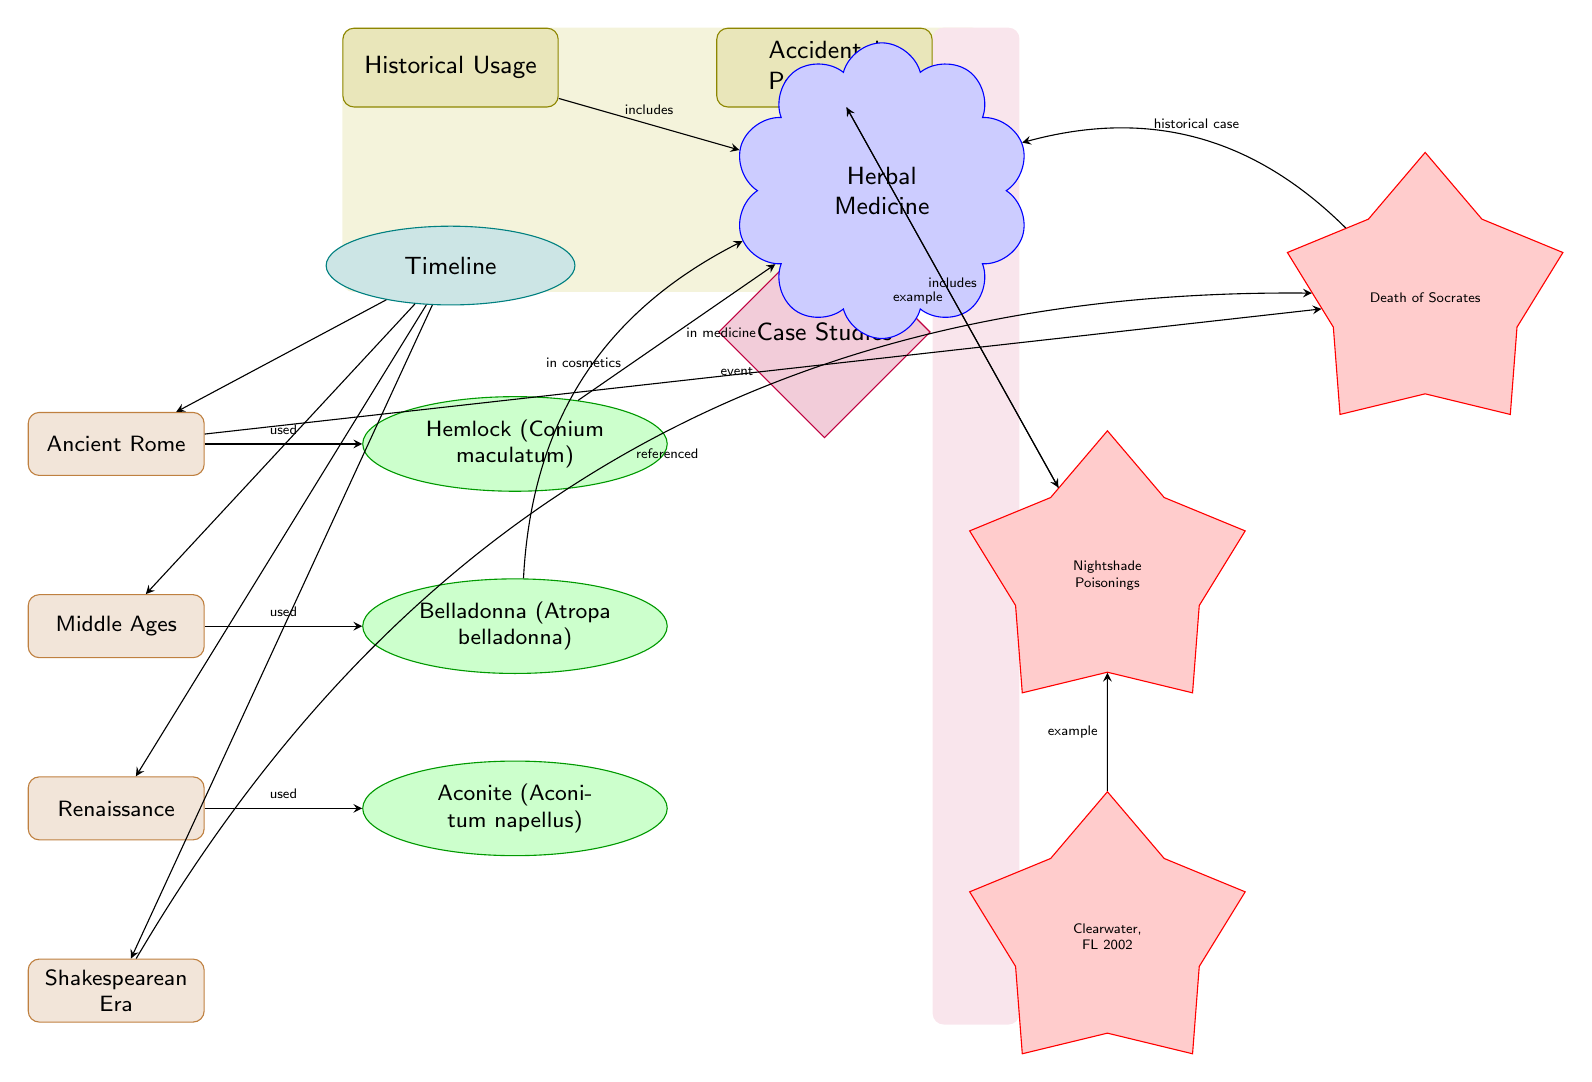What historical figure is associated with Hemlock? The diagram indicates that Socrates is linked to Hemlock as a historical figure through the label "Death of Socrates" directly connected to the Hemlock node. This implies that Socrates was known to have died from Hemlock poisoning.
Answer: Socrates How many historical periods are represented in the diagram? By examining the timeline section of the diagram, we can identify four distinct historical periods: Ancient Rome, Middle Ages, Renaissance, and Shakespearean Era. Therefore, the total count of historical periods is four.
Answer: 4 What plant is noted for its use in cosmetics? The diagram shows that Belladonna is linked specifically to the "in cosmetics" label, which signifies that this plant has historical usage in cosmetic applications.
Answer: Belladonna Which historical period is related to the usage of Aconite? Aconite is shown in the diagram under the Renaissance period, connected directly through the label "used," indicating that Aconite was utilized during that time.
Answer: Renaissance What is the example case of accidental poisoning listed for 2002? The diagram mentions "Clearwater, FL 2002" as an example of an accidental poisoning case associated with Nightshade, indicating that this specific incident occurred in Clearwater, Florida, in the year 2002.
Answer: Clearwater, FL 2002 Which plant is connected to herbal medicine? The diagram connects Hemlock to the herbal medicine category, indicating that Hemlock has been used historically in herbal medicinal practices.
Answer: Hemlock What notable historical case is associated with the love of Socrates? The diagram connects Socrates to the "historical case" label, further specifying that his death from Hemlock poisoning is a significant historical case related to the use of this poisonous plant.
Answer: Death of Socrates Name the category of the node that includes "Nightshade Poisonings." The node for "Nightshade Poisonings" is included within the "Accidental Poisonings" category, indicating that it falls under this classification of poisonings in the diagram.
Answer: Accidental Poisonings How is the Hemlock plant related to medicine in the diagram? The diagram shows an arrow from Hemlock to the "Herbal Medicine" node, with the label "in medicine," showing a direct connection that indicates Hemlock's importance in medicinal applications.
Answer: in medicine 